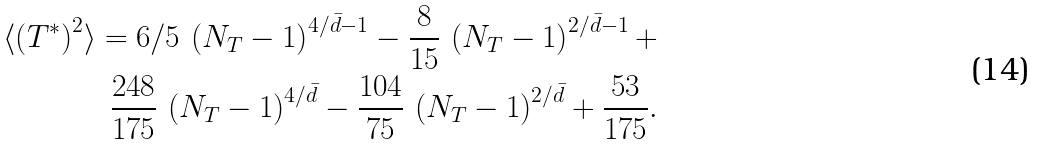Convert formula to latex. <formula><loc_0><loc_0><loc_500><loc_500>\langle \left ( T ^ { * } \right ) ^ { 2 } \rangle = 6 / 5 \, \left ( N _ { T } - 1 \right ) ^ { 4 / { \bar { d } } - 1 } - { \frac { 8 } { 1 5 } } \, \left ( N _ { T } - 1 \right ) ^ { 2 / \bar { d } - 1 } + \\ { \frac { 2 4 8 } { 1 7 5 } } \, \left ( N _ { T } - 1 \right ) ^ { 4 / \bar { d } } - { \frac { 1 0 4 } { 7 5 } } \, \left ( N _ { T } - 1 \right ) ^ { 2 / \bar { d } } + { \frac { 5 3 } { 1 7 5 } } . \\</formula> 